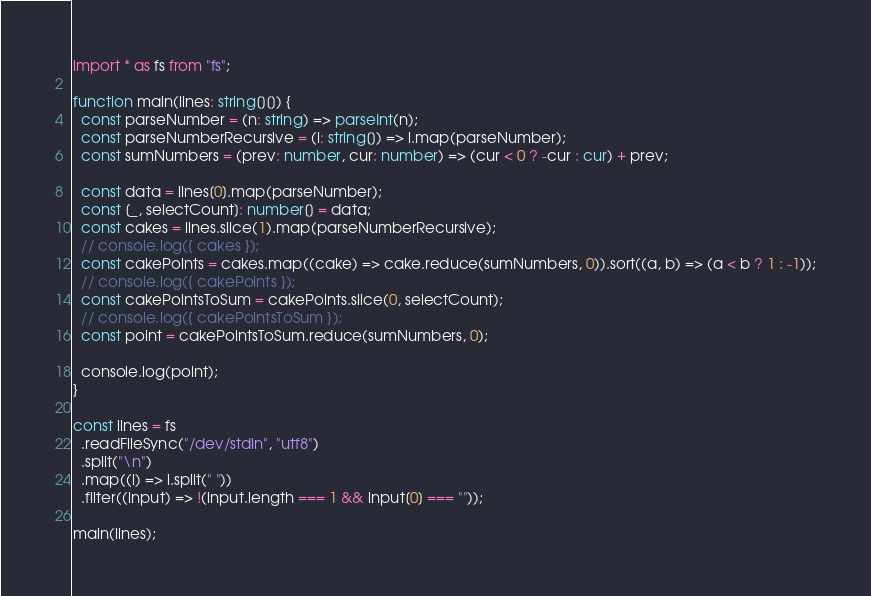Convert code to text. <code><loc_0><loc_0><loc_500><loc_500><_TypeScript_>import * as fs from "fs";

function main(lines: string[][]) {
  const parseNumber = (n: string) => parseInt(n);
  const parseNumberRecursive = (l: string[]) => l.map(parseNumber);
  const sumNumbers = (prev: number, cur: number) => (cur < 0 ? -cur : cur) + prev;

  const data = lines[0].map(parseNumber);
  const [_, selectCount]: number[] = data;
  const cakes = lines.slice(1).map(parseNumberRecursive);
  // console.log({ cakes });
  const cakePoints = cakes.map((cake) => cake.reduce(sumNumbers, 0)).sort((a, b) => (a < b ? 1 : -1));
  // console.log({ cakePoints });
  const cakePointsToSum = cakePoints.slice(0, selectCount);
  // console.log({ cakePointsToSum });
  const point = cakePointsToSum.reduce(sumNumbers, 0);

  console.log(point);
}

const lines = fs
  .readFileSync("/dev/stdin", "utf8")
  .split("\n")
  .map((l) => l.split(" "))
  .filter((input) => !(input.length === 1 && input[0] === ""));

main(lines);
</code> 